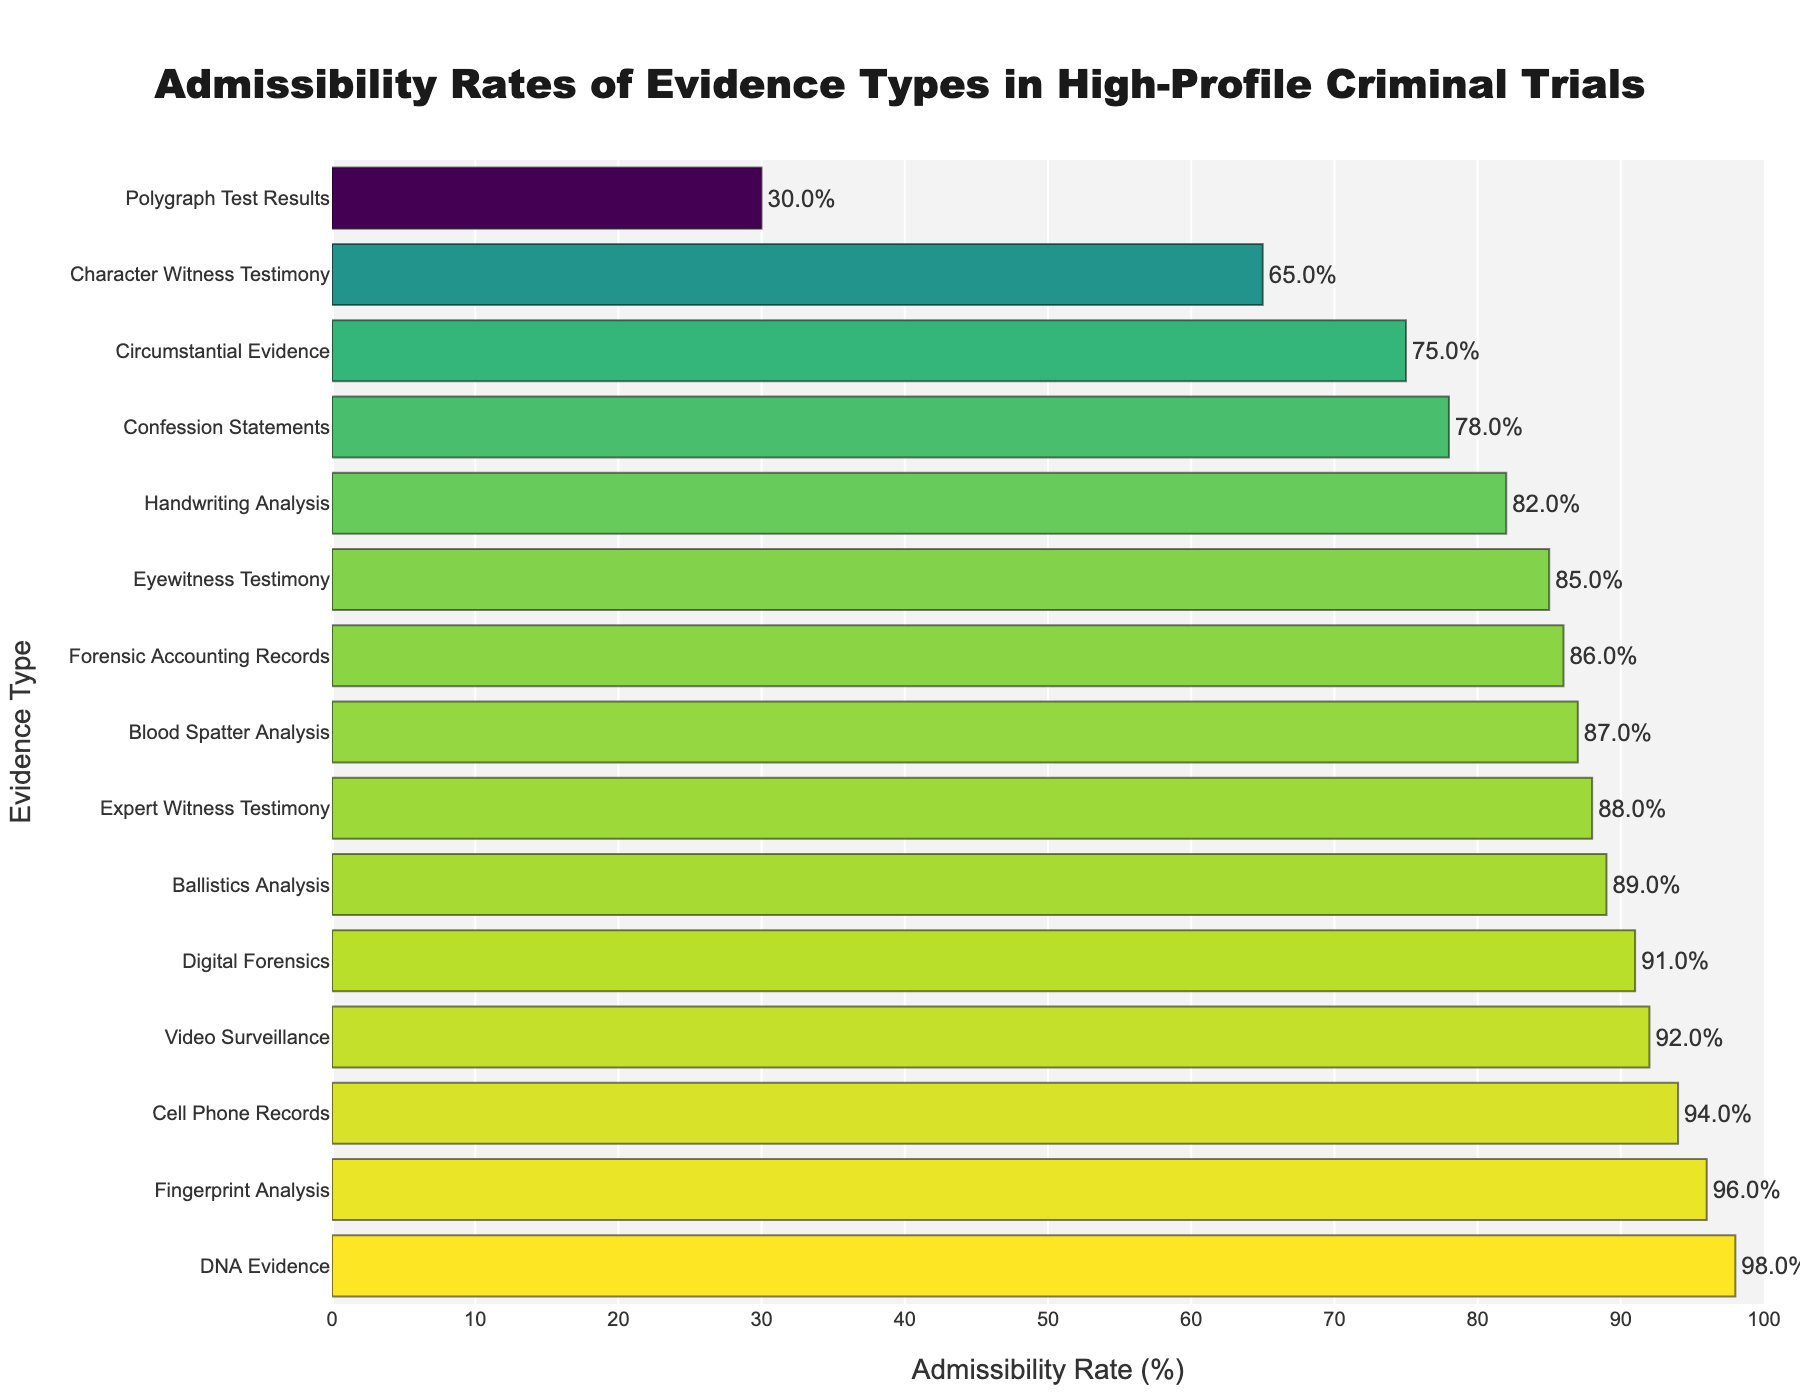Which type of evidence has the highest admissibility rate? By visually inspecting the length of the bars in the figure, the longest bar represents the highest admissibility rate. DNA Evidence has the highest admissibility rate at 98%.
Answer: DNA Evidence Which type of evidence has the lowest admissibility rate? By looking at the shortest bar in the figure, Polygraph Test Results have the lowest admissibility rate at 30%.
Answer: Polygraph Test Results How many evidence types have an admissibility rate of 90% or higher? By counting the number of bars with percentages above or equal to 90%, there are five types: DNA Evidence (98%), Cell Phone Records (94%), Video Surveillance (92%), Digital Forensics (91%), and Fingerprint Analysis (96%).
Answer: 5 Which is more admissible, Eyewitness Testimony or Blood Spatter Analysis? Comparing the lengths of the bars for Eyewitness Testimony (85%) and Blood Spatter Analysis (87%) visually, Blood Spatter Analysis has a higher admissibility rate.
Answer: Blood Spatter Analysis What is the average admissibility rate for DNA Evidence, Fingerprint Analysis, and Ballistics Analysis? Adding the admissibility rates of the three evidence types: DNA Evidence (98%), Fingerprint Analysis (96%), and Ballistics Analysis (89%) gives 283%. Dividing by 3, the average is 283 / 3 = 94.33%.
Answer: 94.33% What is the difference in admissibility rates between Character Witness Testimony and Confession Statements? By subtracting the admissibility rate of Confession Statements (78%) from that of Character Witness Testimony (65%), the difference is 65% - 78% = -13%.
Answer: -13% Which color represents evidence with the highest admissibility rate, and which color represents the lowest? Observing the color scale, the lightest color at the top bar (DNA Evidence, 98%) represents the highest admissibility rate, and the darkest color at the bottom bar (Polygraph Test Results, 30%) represents the lowest.
Answer: Light color (e.g., yellow) for highest, dark color (e.g., dark blue) for lowest If the admissibility rates of Expert Witness Testimony and Handwriting Analysis were to be swapped, which one would be higher? After swapping, Handwriting Analysis would have 88% (the admissibility rate of Expert Witness Testimony), and Expert Witness Testimony would have 82% (the admissibility rate of Handwriting Analysis). Hence, Handwriting Analysis would be higher.
Answer: Handwriting Analysis 